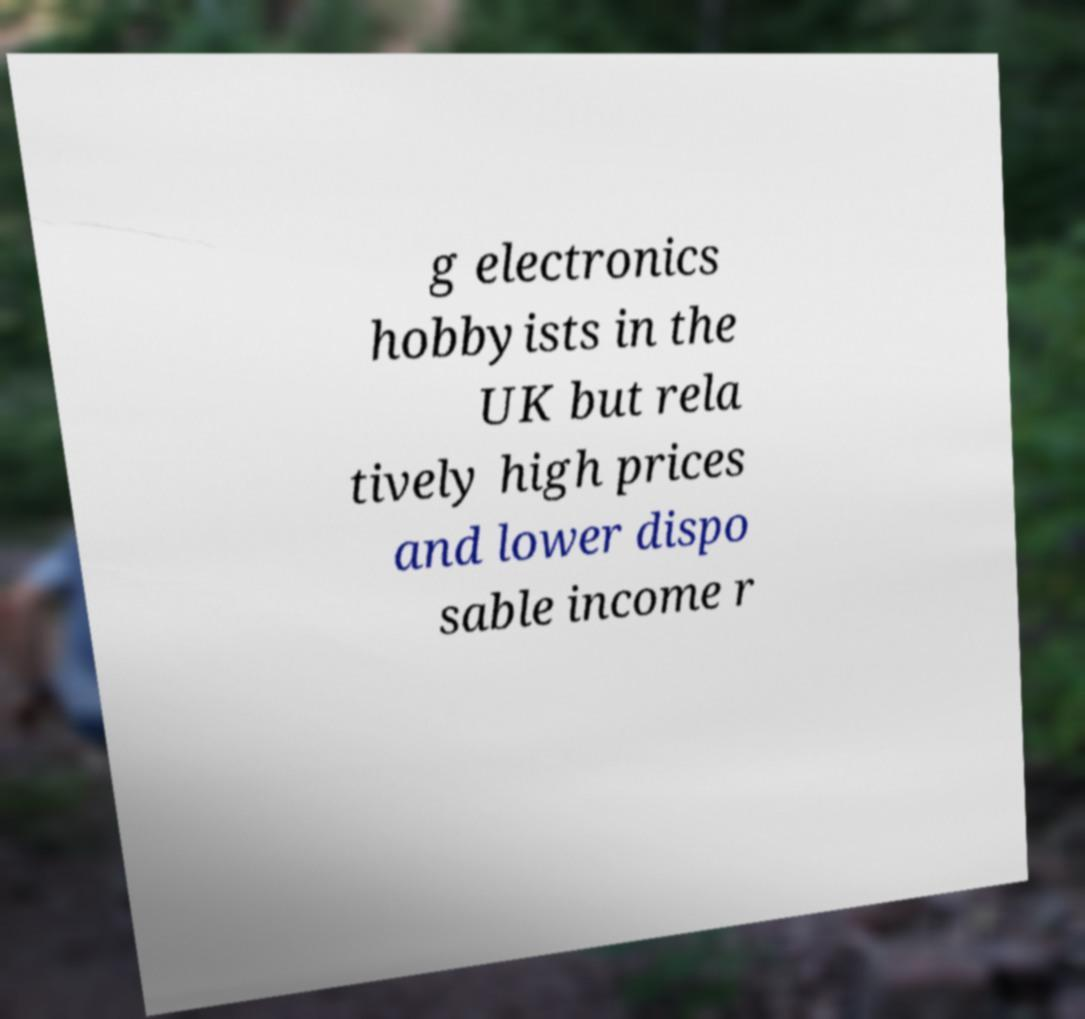What messages or text are displayed in this image? I need them in a readable, typed format. g electronics hobbyists in the UK but rela tively high prices and lower dispo sable income r 